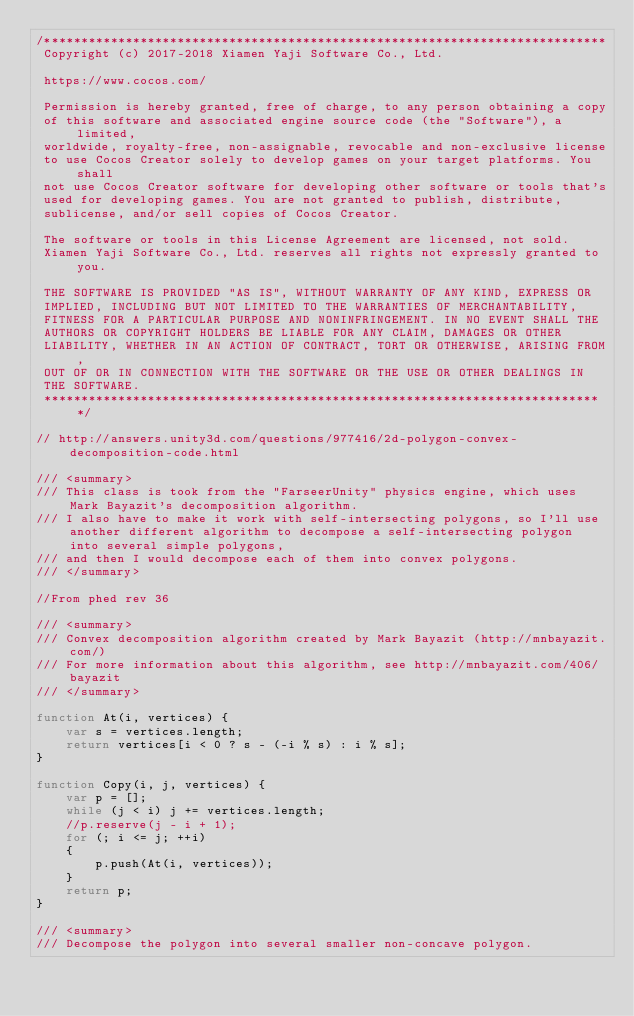Convert code to text. <code><loc_0><loc_0><loc_500><loc_500><_JavaScript_>/****************************************************************************
 Copyright (c) 2017-2018 Xiamen Yaji Software Co., Ltd.

 https://www.cocos.com/

 Permission is hereby granted, free of charge, to any person obtaining a copy
 of this software and associated engine source code (the "Software"), a limited,
 worldwide, royalty-free, non-assignable, revocable and non-exclusive license
 to use Cocos Creator solely to develop games on your target platforms. You shall
 not use Cocos Creator software for developing other software or tools that's
 used for developing games. You are not granted to publish, distribute,
 sublicense, and/or sell copies of Cocos Creator.

 The software or tools in this License Agreement are licensed, not sold.
 Xiamen Yaji Software Co., Ltd. reserves all rights not expressly granted to you.

 THE SOFTWARE IS PROVIDED "AS IS", WITHOUT WARRANTY OF ANY KIND, EXPRESS OR
 IMPLIED, INCLUDING BUT NOT LIMITED TO THE WARRANTIES OF MERCHANTABILITY,
 FITNESS FOR A PARTICULAR PURPOSE AND NONINFRINGEMENT. IN NO EVENT SHALL THE
 AUTHORS OR COPYRIGHT HOLDERS BE LIABLE FOR ANY CLAIM, DAMAGES OR OTHER
 LIABILITY, WHETHER IN AN ACTION OF CONTRACT, TORT OR OTHERWISE, ARISING FROM,
 OUT OF OR IN CONNECTION WITH THE SOFTWARE OR THE USE OR OTHER DEALINGS IN
 THE SOFTWARE.
 ****************************************************************************/

// http://answers.unity3d.com/questions/977416/2d-polygon-convex-decomposition-code.html

/// <summary>
/// This class is took from the "FarseerUnity" physics engine, which uses Mark Bayazit's decomposition algorithm.
/// I also have to make it work with self-intersecting polygons, so I'll use another different algorithm to decompose a self-intersecting polygon into several simple polygons,
/// and then I would decompose each of them into convex polygons.
/// </summary>

//From phed rev 36

/// <summary>
/// Convex decomposition algorithm created by Mark Bayazit (http://mnbayazit.com/)
/// For more information about this algorithm, see http://mnbayazit.com/406/bayazit
/// </summary>
 
function At(i, vertices) {
    var s = vertices.length;
    return vertices[i < 0 ? s - (-i % s) : i % s];
}

function Copy(i, j, vertices) {
    var p = [];
    while (j < i) j += vertices.length;
    //p.reserve(j - i + 1);
    for (; i <= j; ++i)
    {
        p.push(At(i, vertices));
    }
    return p;
}

/// <summary>
/// Decompose the polygon into several smaller non-concave polygon.</code> 